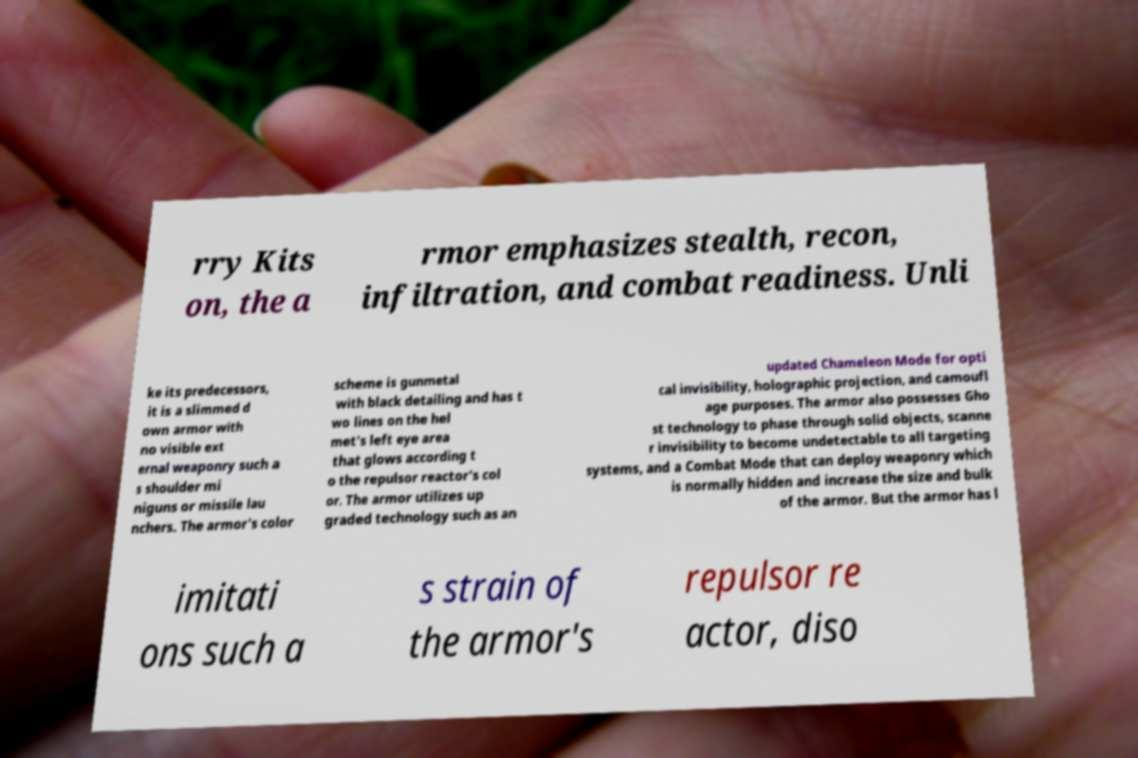What messages or text are displayed in this image? I need them in a readable, typed format. rry Kits on, the a rmor emphasizes stealth, recon, infiltration, and combat readiness. Unli ke its predecessors, it is a slimmed d own armor with no visible ext ernal weaponry such a s shoulder mi niguns or missile lau nchers. The armor's color scheme is gunmetal with black detailing and has t wo lines on the hel met's left eye area that glows according t o the repulsor reactor's col or. The armor utilizes up graded technology such as an updated Chameleon Mode for opti cal invisibility, holographic projection, and camoufl age purposes. The armor also possesses Gho st technology to phase through solid objects, scanne r invisibility to become undetectable to all targeting systems, and a Combat Mode that can deploy weaponry which is normally hidden and increase the size and bulk of the armor. But the armor has l imitati ons such a s strain of the armor's repulsor re actor, diso 